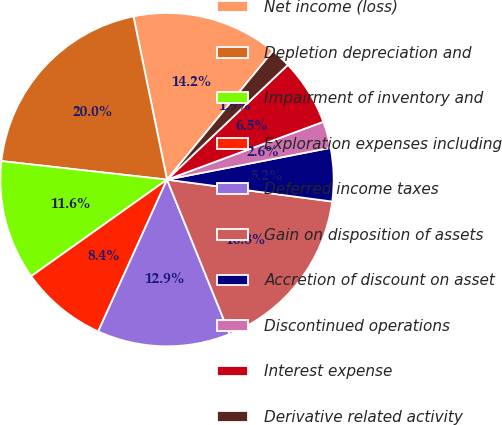Convert chart to OTSL. <chart><loc_0><loc_0><loc_500><loc_500><pie_chart><fcel>Net income (loss)<fcel>Depletion depreciation and<fcel>Impairment of inventory and<fcel>Exploration expenses including<fcel>Deferred income taxes<fcel>Gain on disposition of assets<fcel>Accretion of discount on asset<fcel>Discontinued operations<fcel>Interest expense<fcel>Derivative related activity<nl><fcel>14.19%<fcel>20.0%<fcel>11.61%<fcel>8.39%<fcel>12.9%<fcel>16.77%<fcel>5.16%<fcel>2.58%<fcel>6.45%<fcel>1.94%<nl></chart> 